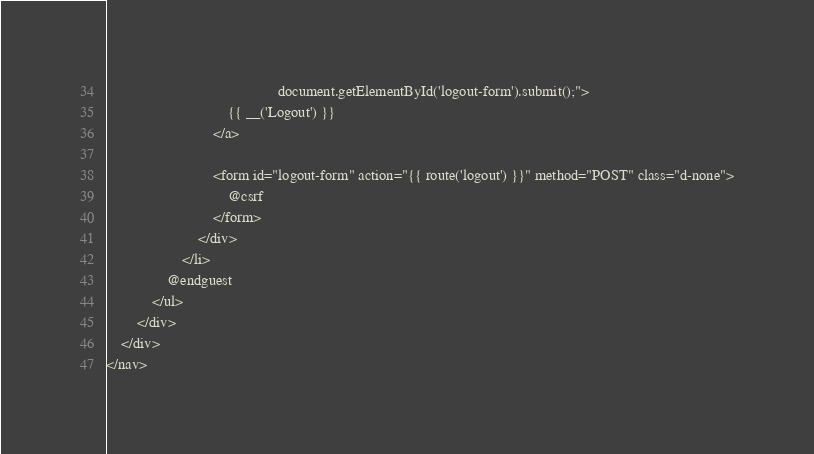<code> <loc_0><loc_0><loc_500><loc_500><_PHP_>                                             document.getElementById('logout-form').submit();">
                                {{ __('Logout') }}
                            </a>

                            <form id="logout-form" action="{{ route('logout') }}" method="POST" class="d-none">
                                @csrf
                            </form>
                        </div>
                    </li>
                @endguest
            </ul>
        </div>
    </div>
</nav></code> 